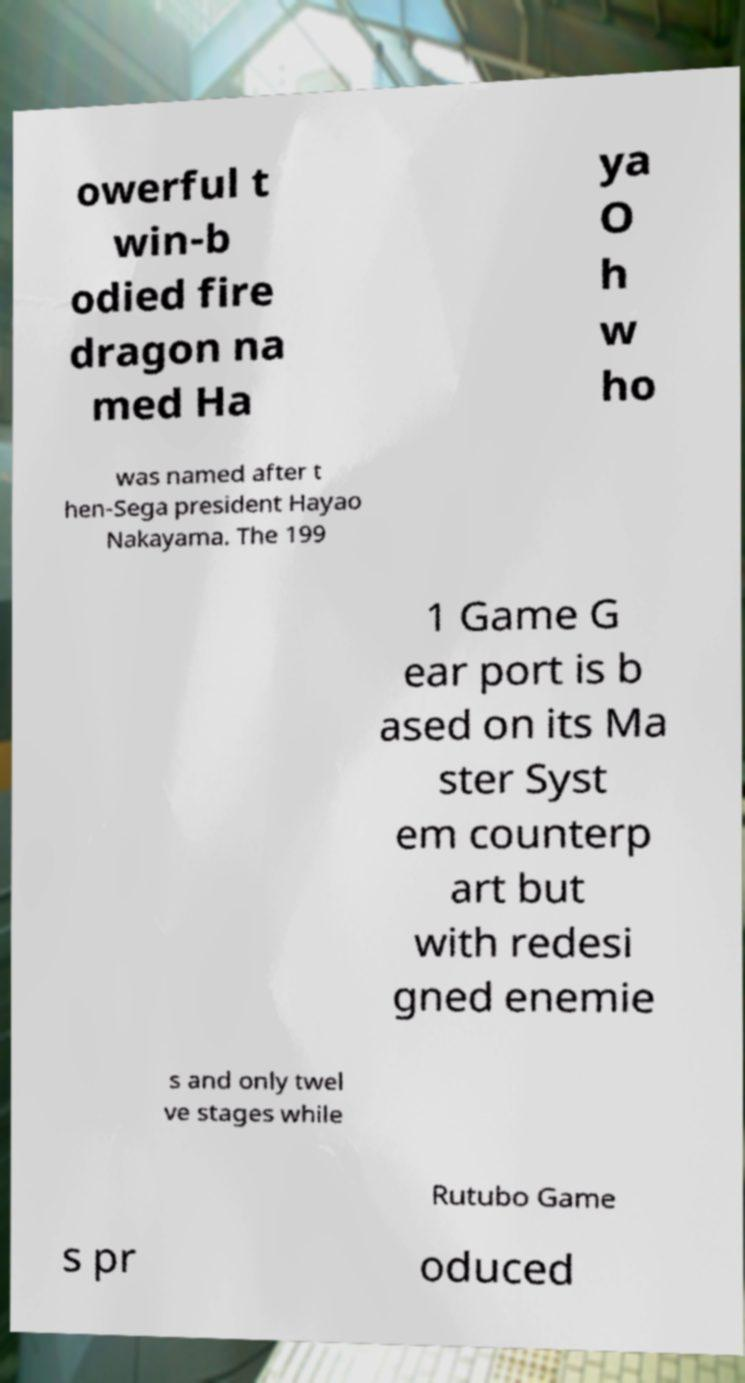Could you assist in decoding the text presented in this image and type it out clearly? owerful t win-b odied fire dragon na med Ha ya O h w ho was named after t hen-Sega president Hayao Nakayama. The 199 1 Game G ear port is b ased on its Ma ster Syst em counterp art but with redesi gned enemie s and only twel ve stages while Rutubo Game s pr oduced 